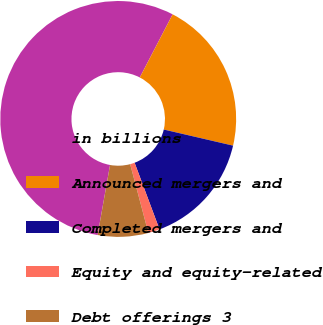Convert chart to OTSL. <chart><loc_0><loc_0><loc_500><loc_500><pie_chart><fcel>in billions<fcel>Announced mergers and<fcel>Completed mergers and<fcel>Equity and equity-related<fcel>Debt offerings 3<nl><fcel>54.84%<fcel>21.0%<fcel>15.67%<fcel>1.58%<fcel>6.91%<nl></chart> 